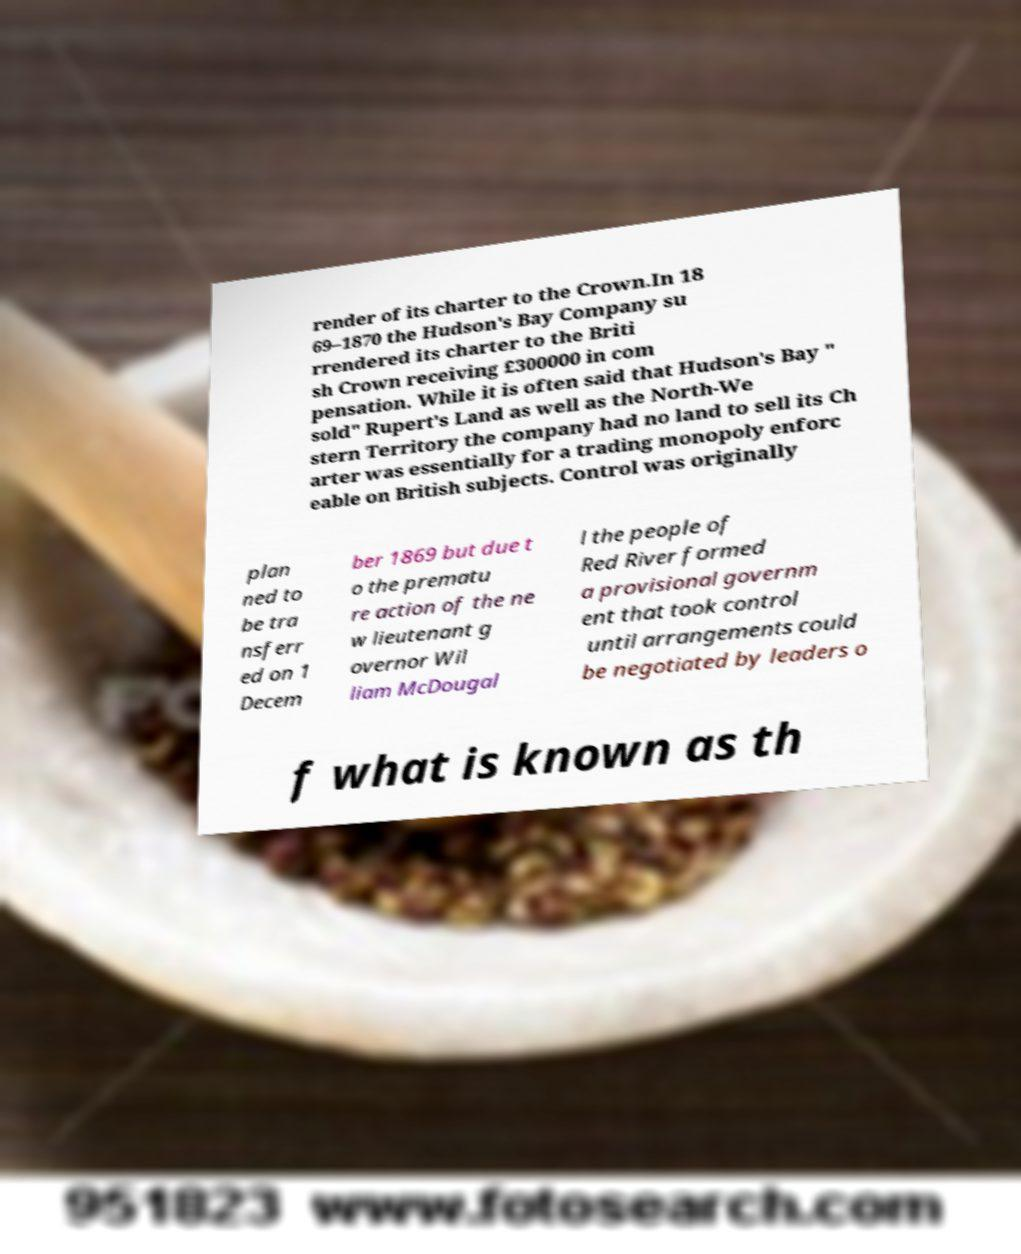Could you assist in decoding the text presented in this image and type it out clearly? render of its charter to the Crown.In 18 69–1870 the Hudson's Bay Company su rrendered its charter to the Briti sh Crown receiving £300000 in com pensation. While it is often said that Hudson's Bay " sold" Rupert's Land as well as the North-We stern Territory the company had no land to sell its Ch arter was essentially for a trading monopoly enforc eable on British subjects. Control was originally plan ned to be tra nsferr ed on 1 Decem ber 1869 but due t o the prematu re action of the ne w lieutenant g overnor Wil liam McDougal l the people of Red River formed a provisional governm ent that took control until arrangements could be negotiated by leaders o f what is known as th 